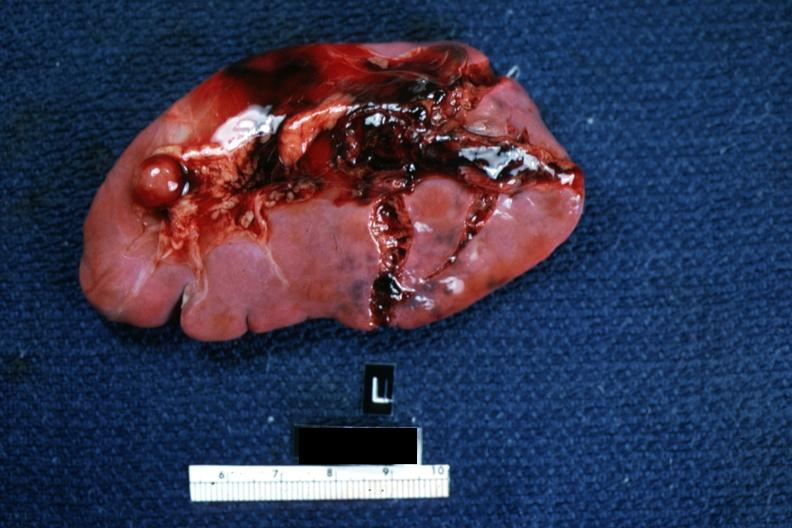what is present?
Answer the question using a single word or phrase. Traumatic rupture 